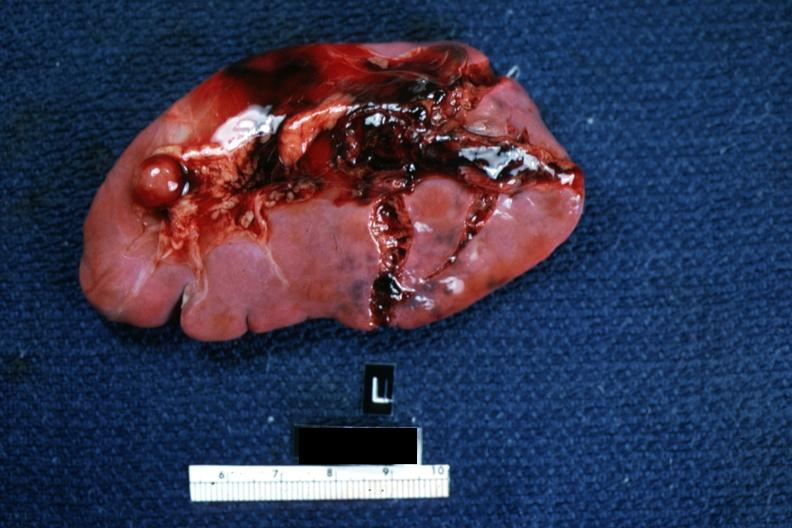what is present?
Answer the question using a single word or phrase. Traumatic rupture 